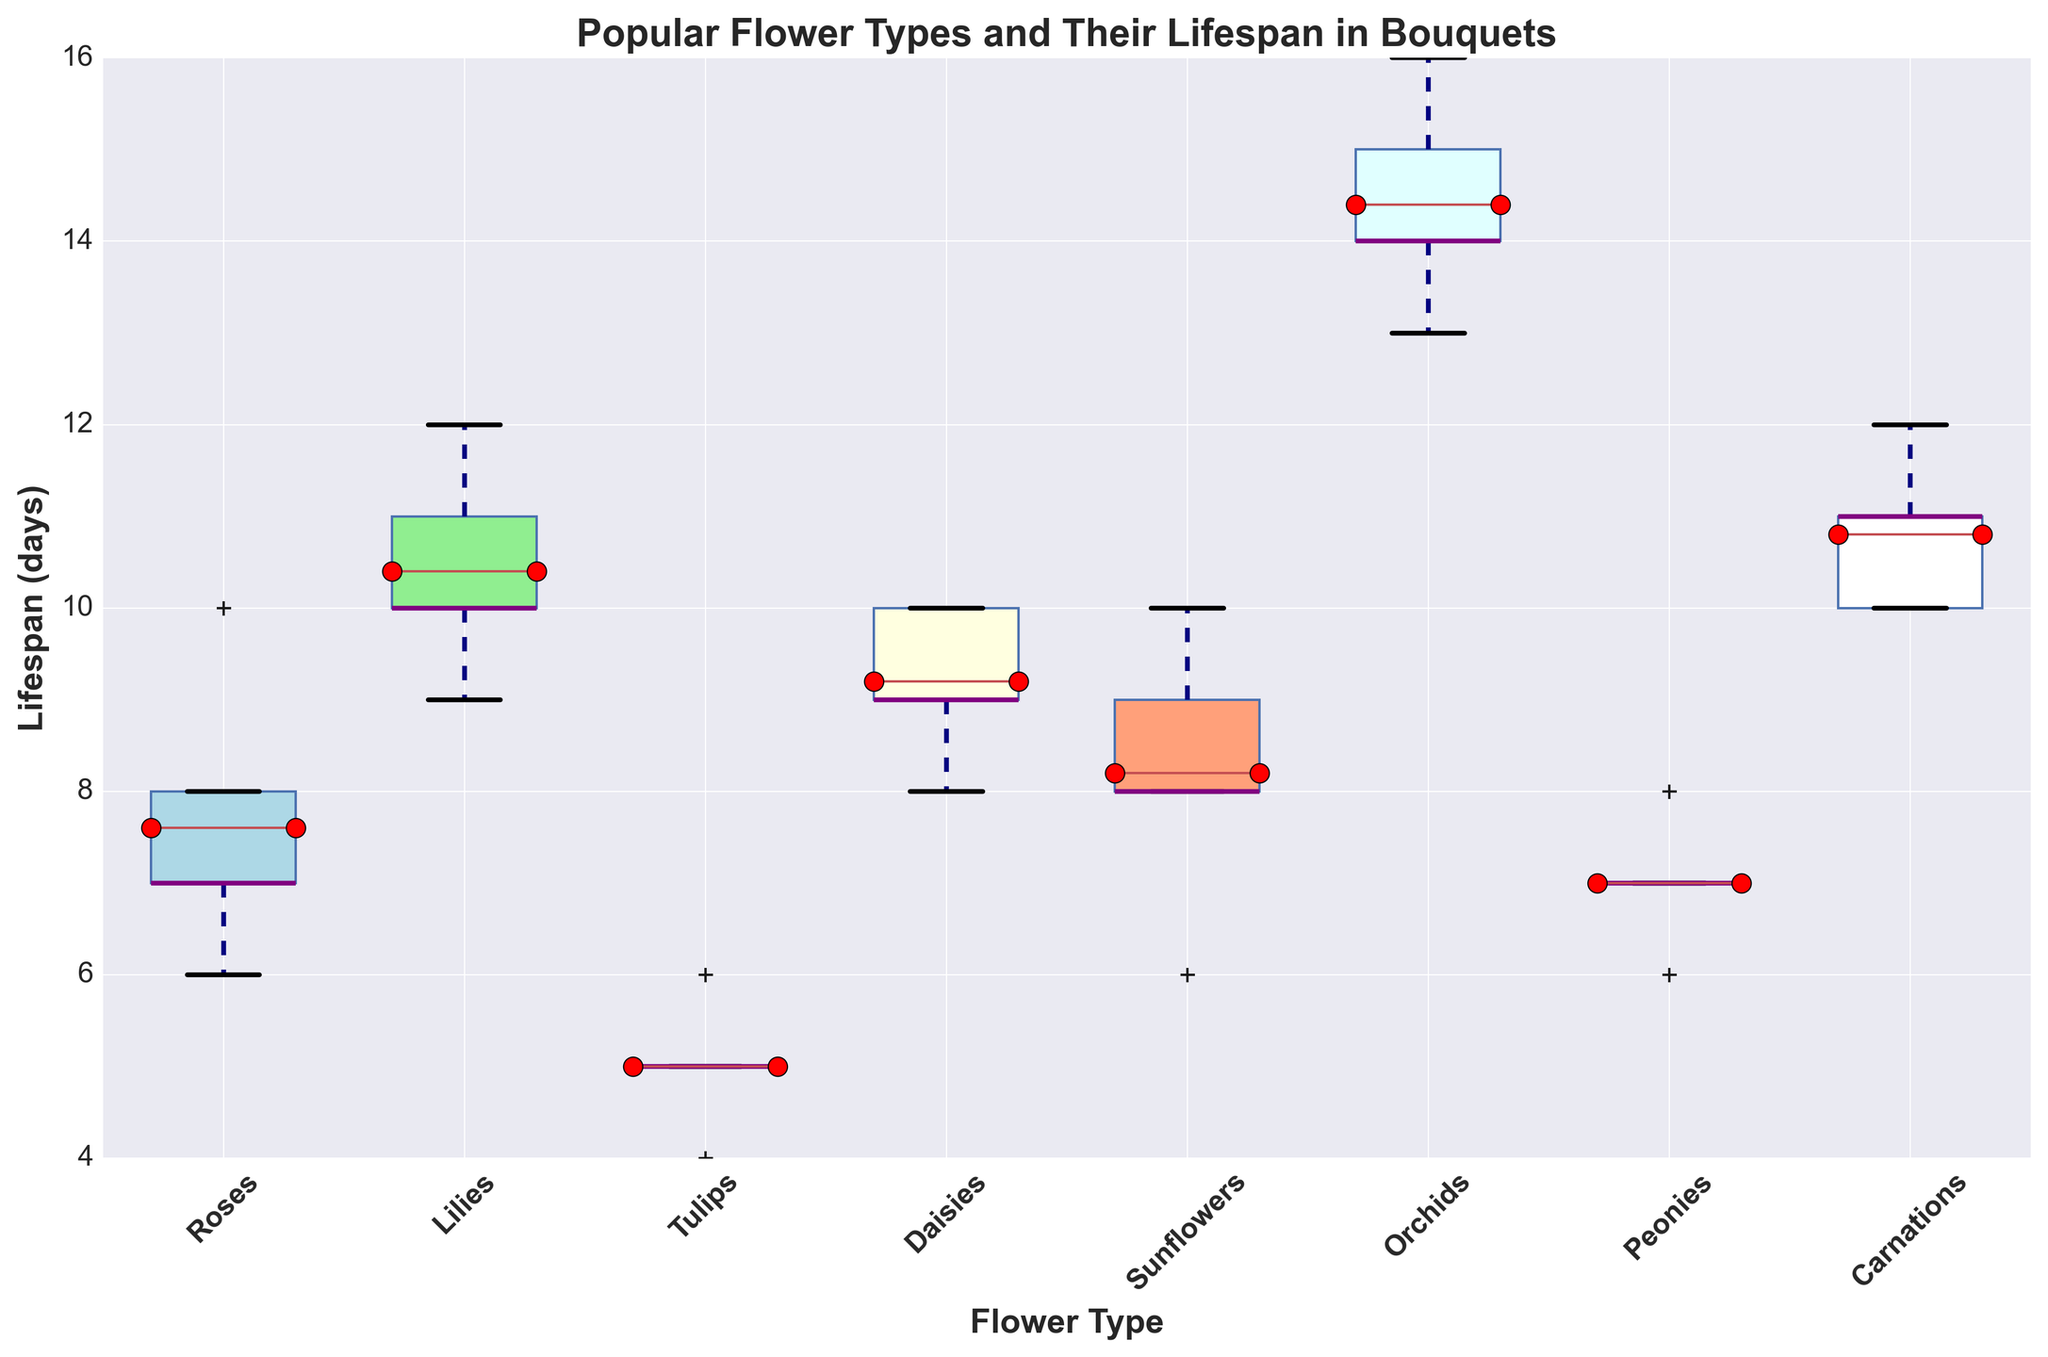What is the median lifespan of Orchids? The box plot indicates the median lifespan with a horizontal line within the box for Orchids. By locating the horizontal line within the Orchids' box, we see that the median lifespan is 14 days.
Answer: 14 Which flower type has the highest mean lifespan? The box plot shows the mean values as red dots with black edges. By comparing the positions of the dots across all flower types, we see that Orchids have the highest mean lifespan.
Answer: Orchids What is the range of lifespan for Tulips? The range is the difference between the maximum and minimum values shown by the top and bottom whiskers of the Tulips’ box plot. The minimum is 4 days, and the maximum is 6 days, so the range is 6 - 4 = 2 days.
Answer: 2 Which flower type has the smallest interquartile range (IQR) for lifespan? The IQR is the length of the box in the box plot. By comparing the lengths of the boxes, we can determine that Tulips have the smallest IQR.
Answer: Tulips How does the maximum lifespan of Roses compare to that of Sunflowers? The maximum lifespan is determined by the top whisker of each box plot. The top whisker for Roses extends to 10 days, and for Sunflowers, it also extends to 10 days, meaning both have the same maximum lifespan.
Answer: Equal What is the median lifespan of Daisies and how does it compare to the median lifespan of Peonies? The median lifespan is indicated by the horizontal line within each box. The median lifespan of Daisies is 9.5 days, while for Peonies, it is 7 days. Daisies have a higher median lifespan compared to Peonies.
Answer: Daisies have a higher median lifespan Which flower type shows the greatest variability in lifespan and how can you tell? Variability can be assessed by looking at the overall spread, including whiskers and outliers. Orchids show the greatest variability as their box plot spans a larger range of days, from 13 to 16 days.
Answer: Orchids If I want a bouquet to last around 12 days, which flower types should I consider based on their mean lifespans? The box plot shows mean values as red dots. By checking if the mean lifespan is around 12 days, we see that Carnations and Lilies should be considered as they have mean lifespans close to 12 days.
Answer: Carnations and Lilies 